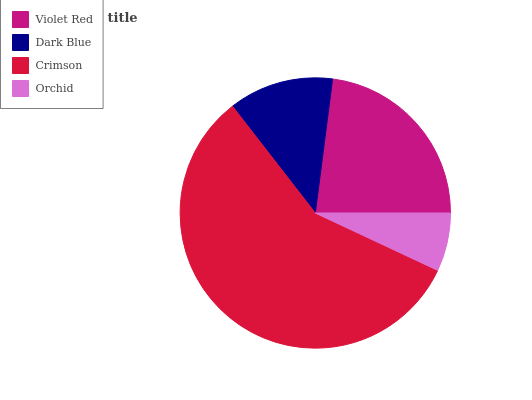Is Orchid the minimum?
Answer yes or no. Yes. Is Crimson the maximum?
Answer yes or no. Yes. Is Dark Blue the minimum?
Answer yes or no. No. Is Dark Blue the maximum?
Answer yes or no. No. Is Violet Red greater than Dark Blue?
Answer yes or no. Yes. Is Dark Blue less than Violet Red?
Answer yes or no. Yes. Is Dark Blue greater than Violet Red?
Answer yes or no. No. Is Violet Red less than Dark Blue?
Answer yes or no. No. Is Violet Red the high median?
Answer yes or no. Yes. Is Dark Blue the low median?
Answer yes or no. Yes. Is Dark Blue the high median?
Answer yes or no. No. Is Crimson the low median?
Answer yes or no. No. 